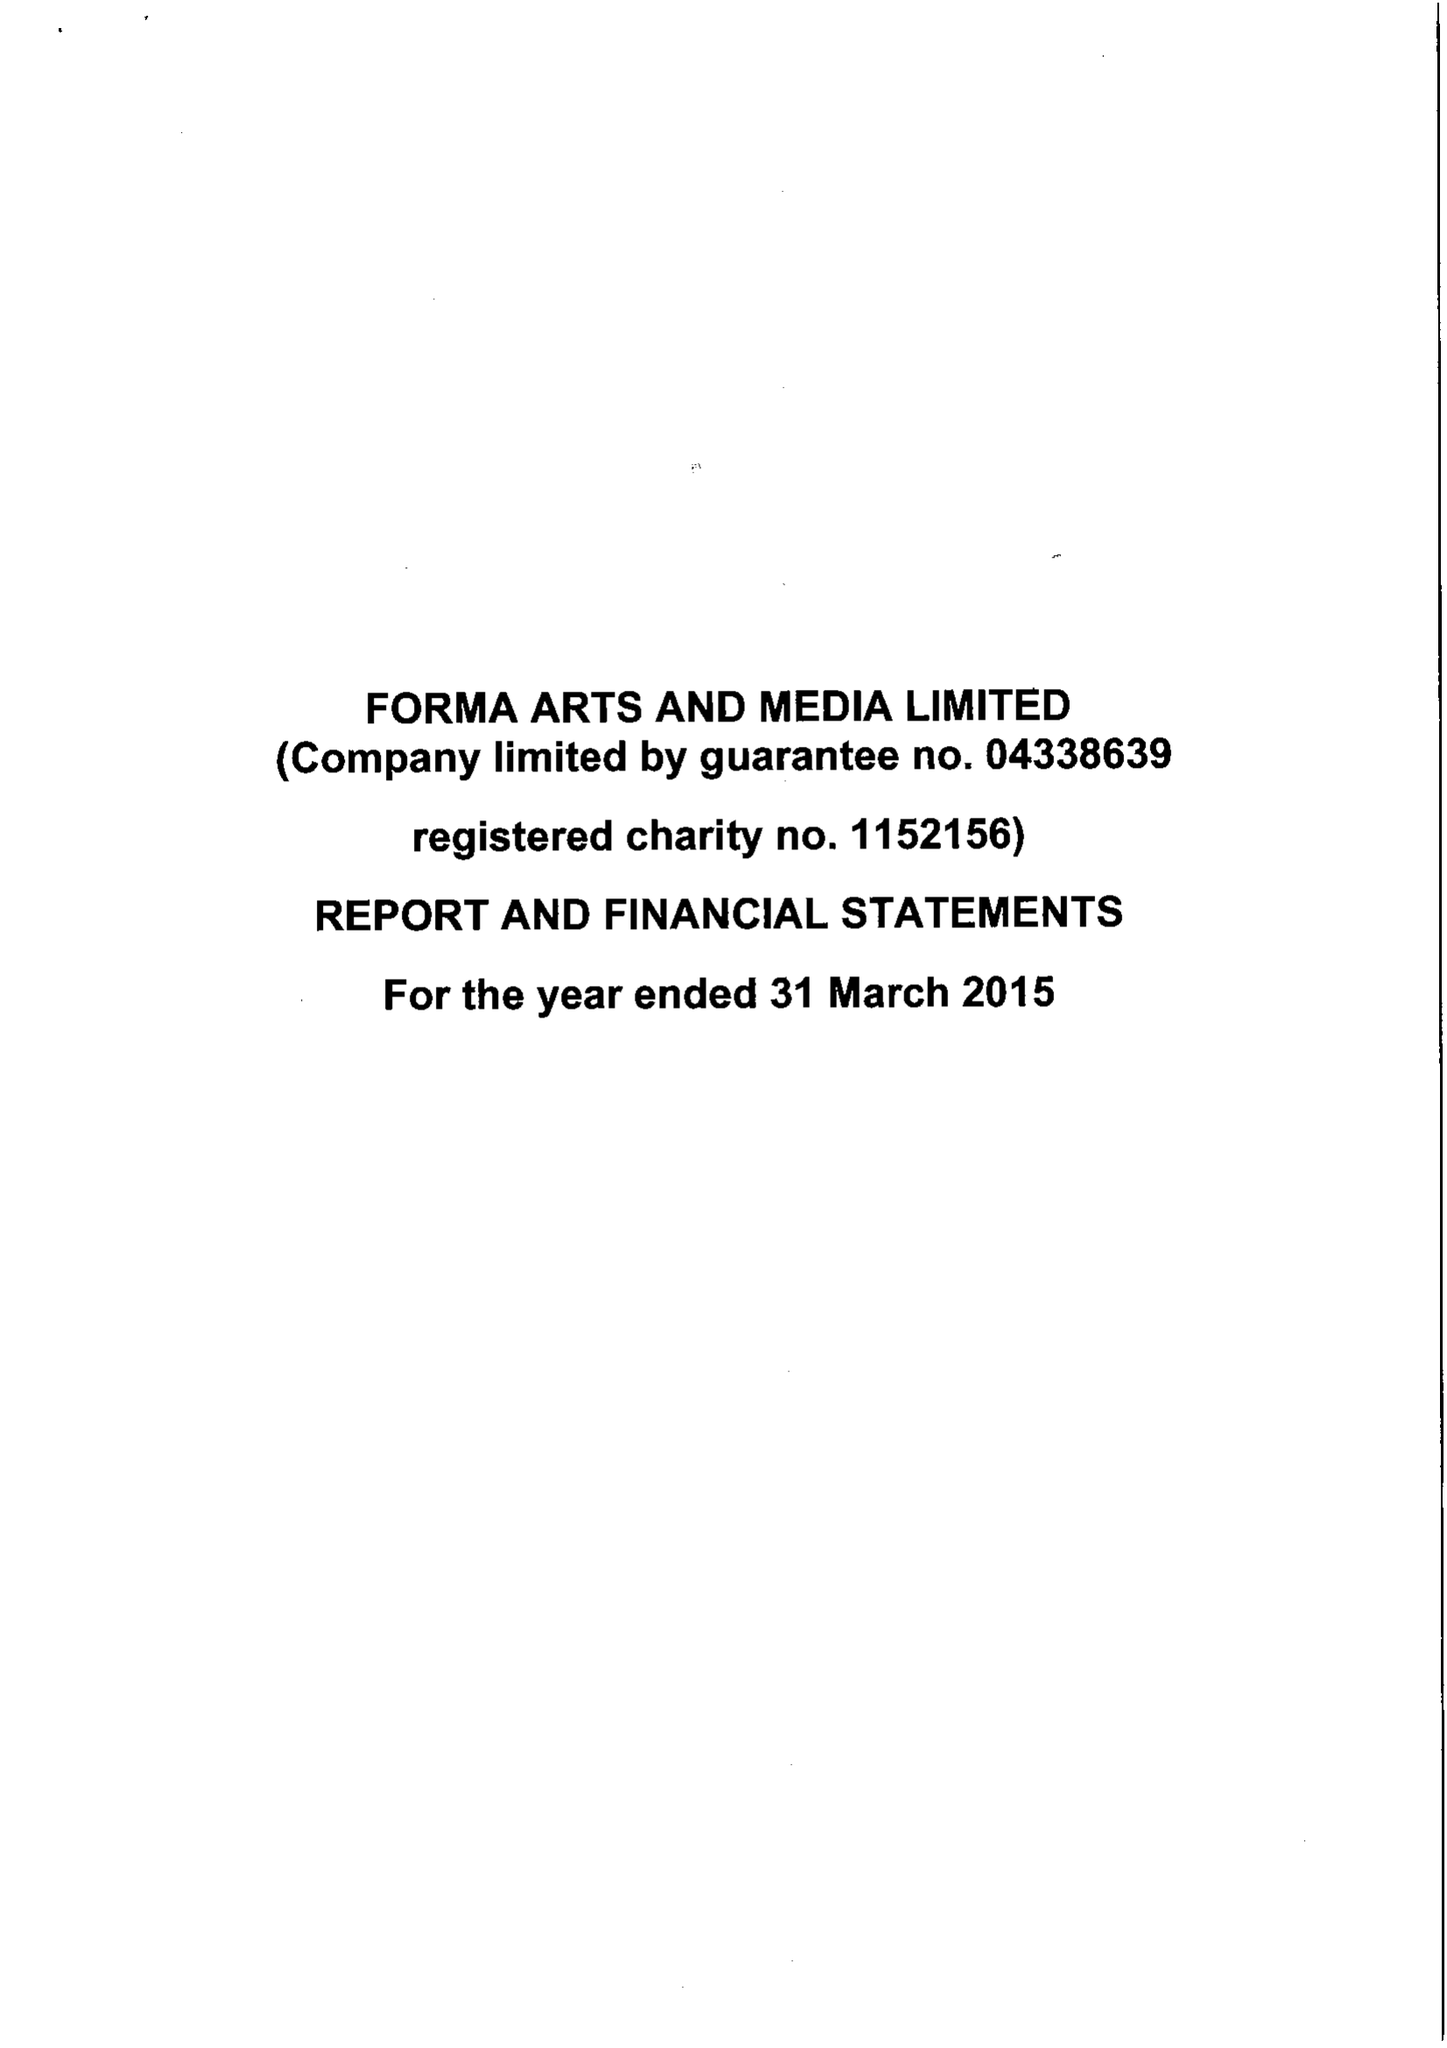What is the value for the address__post_town?
Answer the question using a single word or phrase. None 